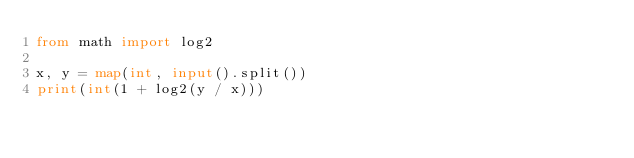Convert code to text. <code><loc_0><loc_0><loc_500><loc_500><_Python_>from math import log2

x, y = map(int, input().split())
print(int(1 + log2(y / x)))</code> 